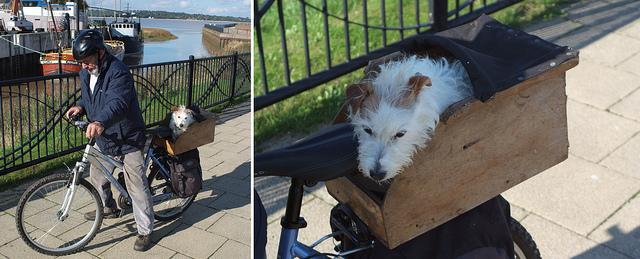Who placed this animal in the box?

Choices:
A) hobo
B) dorothy
C) bike rider
D) wicked witch bike rider 